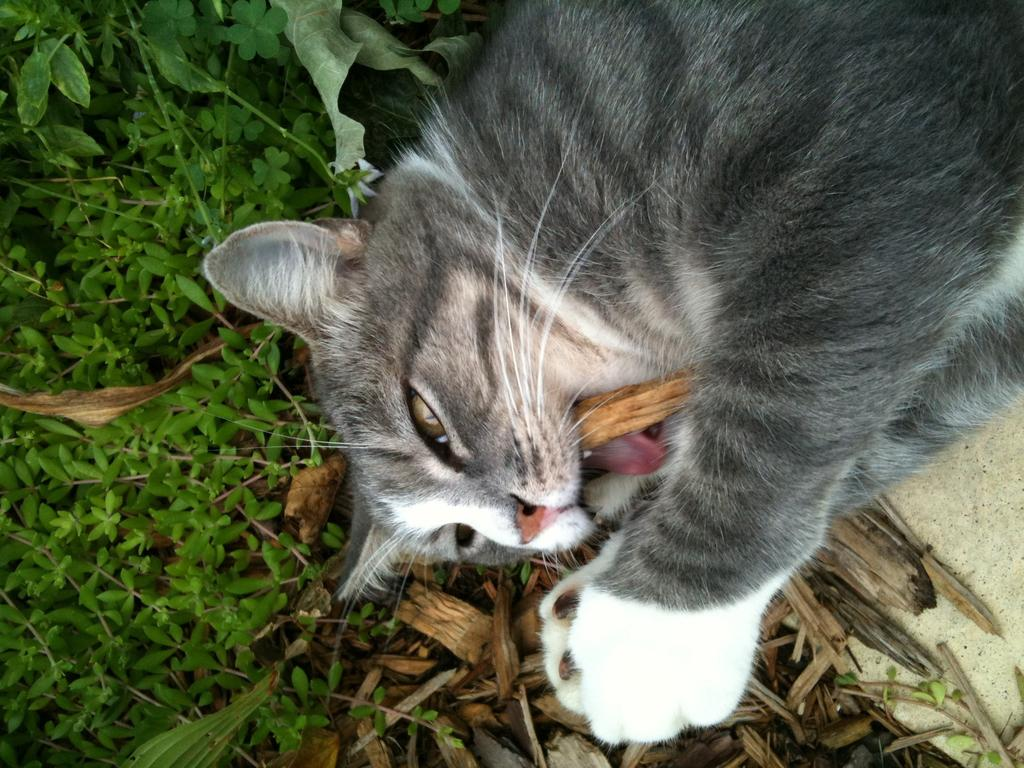What type of animal is in the image? There is a cat in the image. Can you describe the appearance of the cat? The cat is black and white in color. What type of natural environment is visible in the image? There is grass visible in the image. What other object can be seen in the image? There is a plant on the side in the image. What type of legal advice is the cat providing in the image? There is no indication in the image that the cat is providing legal advice or acting as a judge. 